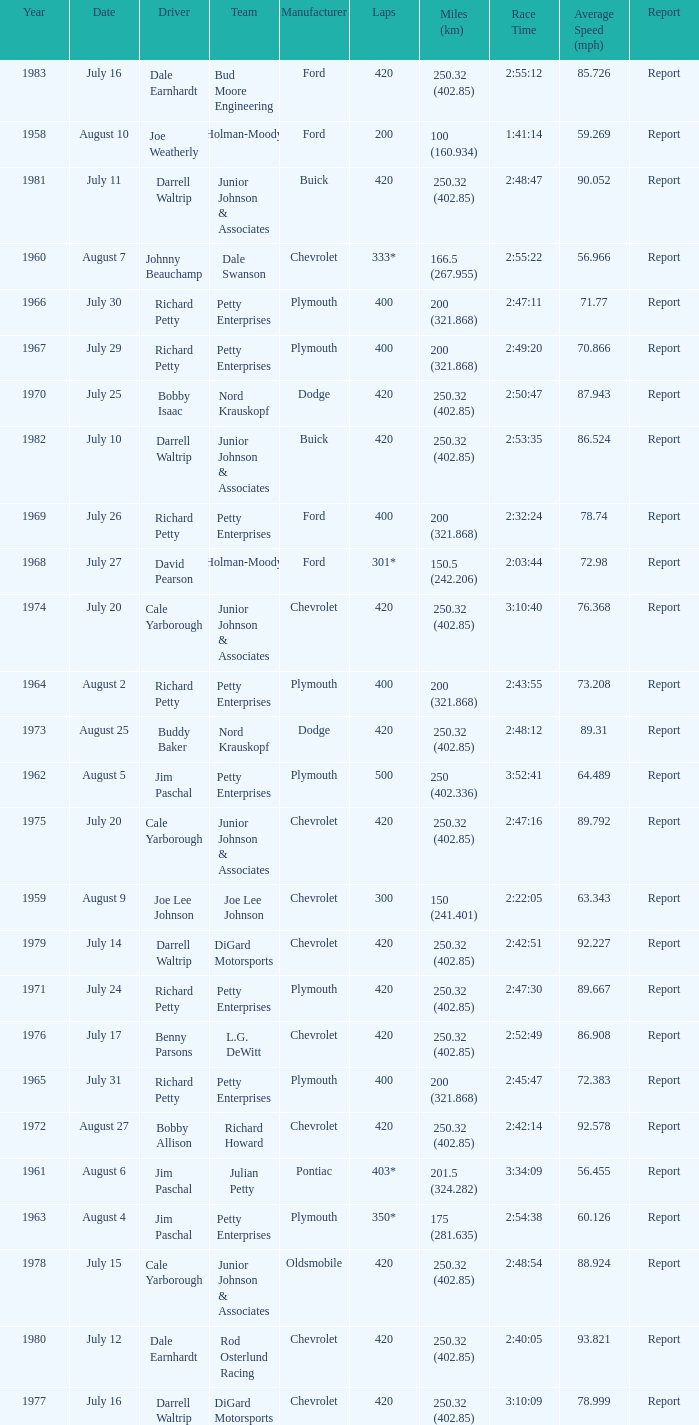What year had a race with 301* laps? 1968.0. 